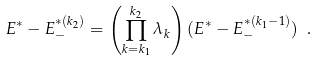Convert formula to latex. <formula><loc_0><loc_0><loc_500><loc_500>E ^ { * } - E ^ { * ( k _ { 2 } ) } _ { - } = \left ( \prod ^ { k _ { 2 } } _ { k = k _ { 1 } } \lambda _ { k } \right ) ( E ^ { * } - E ^ { * ( k _ { 1 } - 1 ) } _ { - } ) \ .</formula> 